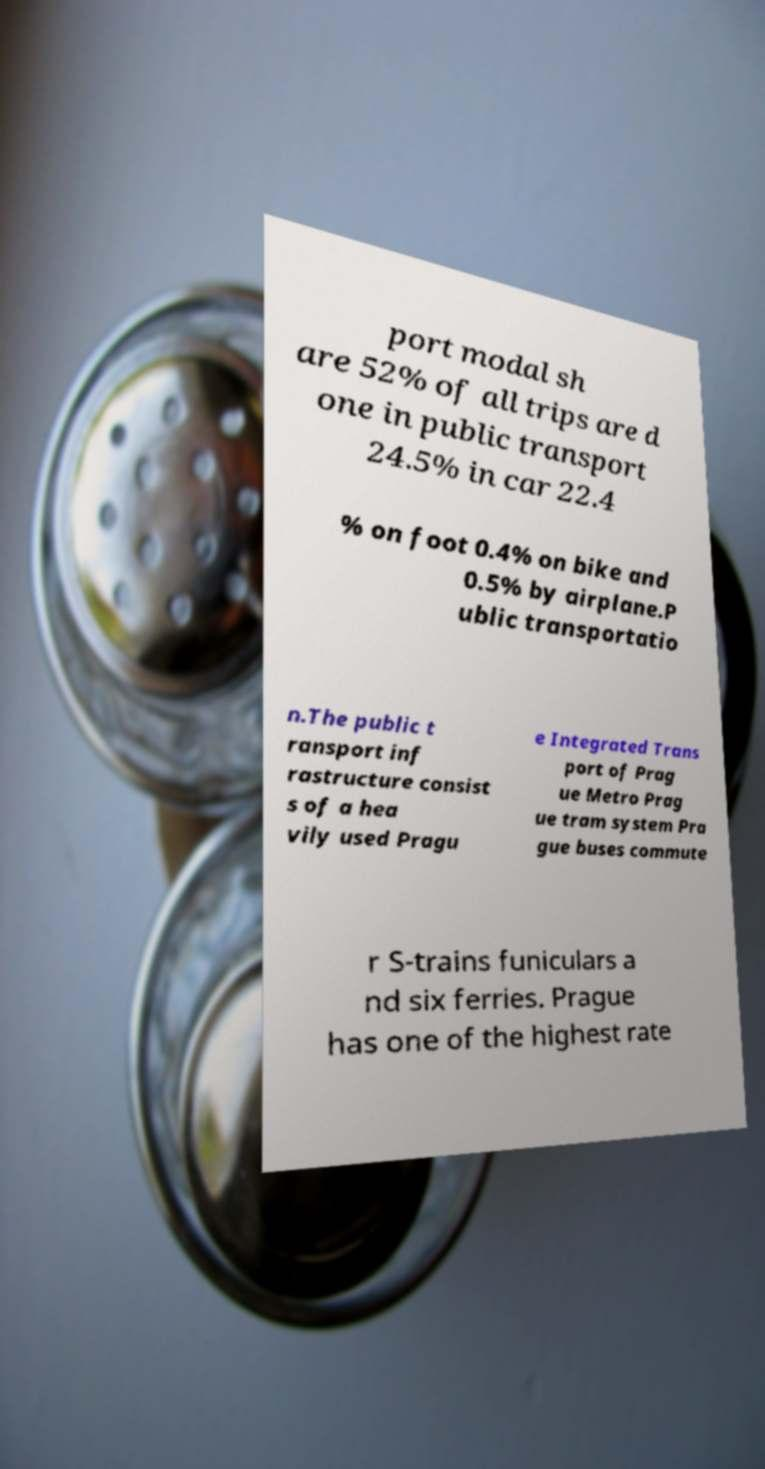What messages or text are displayed in this image? I need them in a readable, typed format. port modal sh are 52% of all trips are d one in public transport 24.5% in car 22.4 % on foot 0.4% on bike and 0.5% by airplane.P ublic transportatio n.The public t ransport inf rastructure consist s of a hea vily used Pragu e Integrated Trans port of Prag ue Metro Prag ue tram system Pra gue buses commute r S-trains funiculars a nd six ferries. Prague has one of the highest rate 